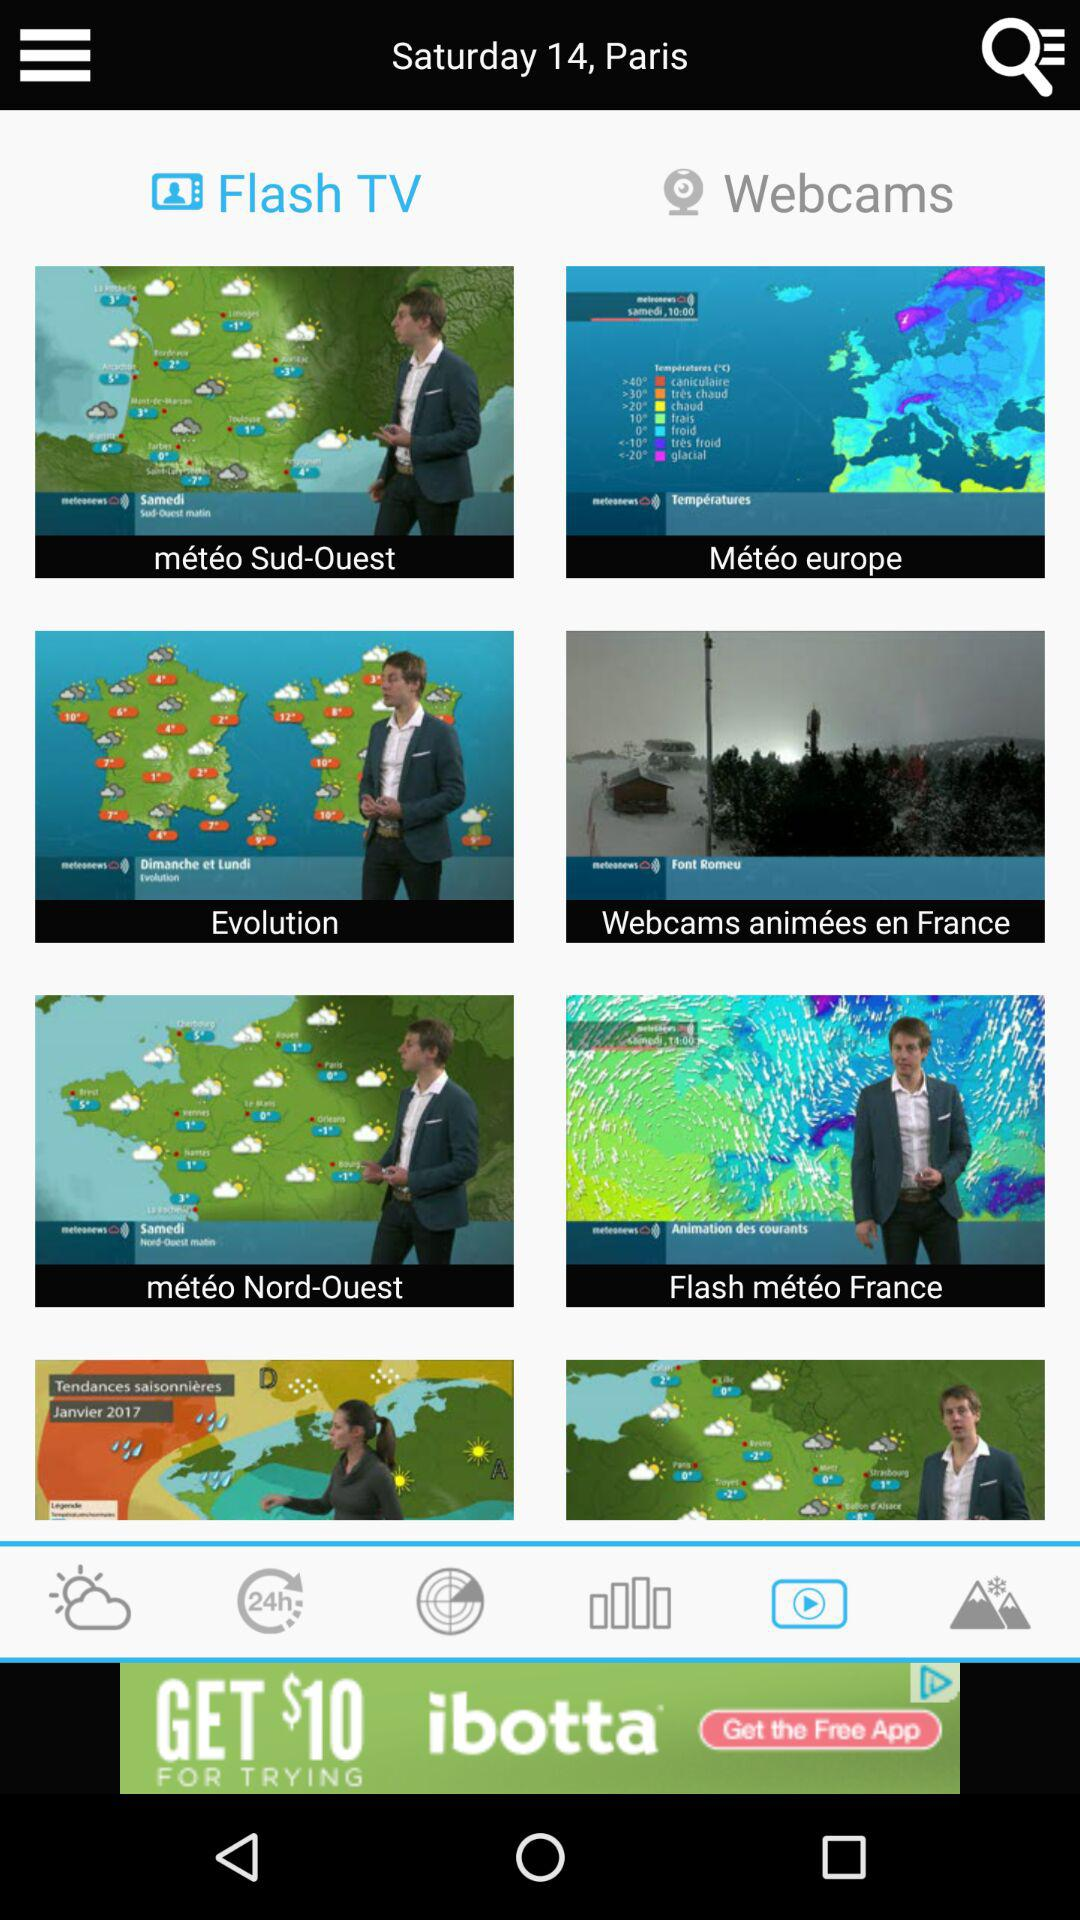Which tab is selected? The selected tabs are "Flash TV" and "VIDEOS". 